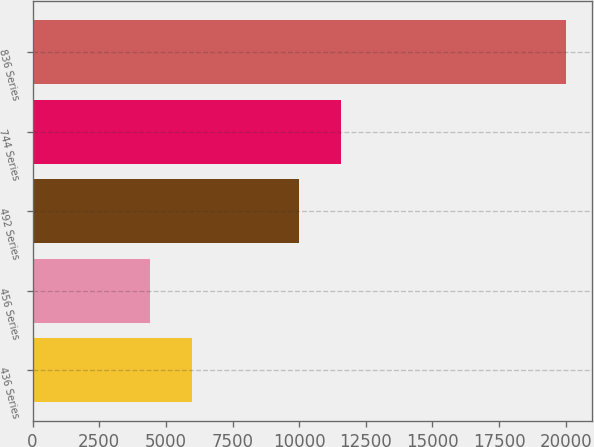Convert chart. <chart><loc_0><loc_0><loc_500><loc_500><bar_chart><fcel>436 Series<fcel>456 Series<fcel>492 Series<fcel>744 Series<fcel>836 Series<nl><fcel>5992<fcel>4389<fcel>10000<fcel>11561.1<fcel>20000<nl></chart> 